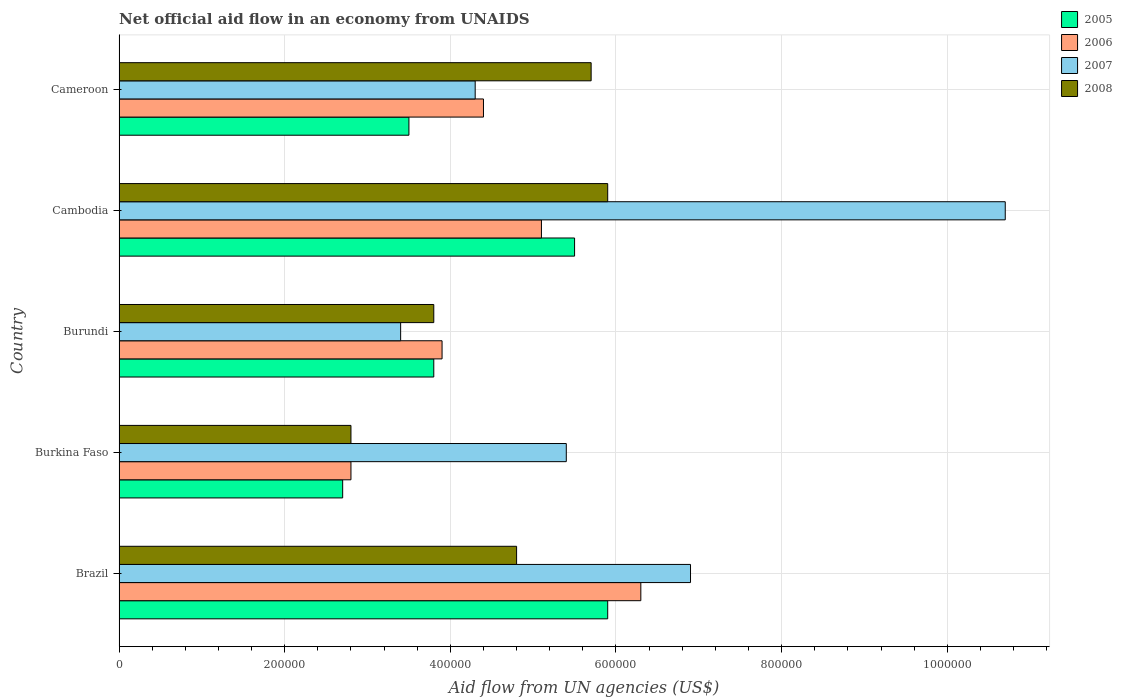Are the number of bars on each tick of the Y-axis equal?
Ensure brevity in your answer.  Yes. What is the label of the 2nd group of bars from the top?
Provide a succinct answer. Cambodia. In how many cases, is the number of bars for a given country not equal to the number of legend labels?
Your answer should be very brief. 0. What is the net official aid flow in 2007 in Burkina Faso?
Provide a succinct answer. 5.40e+05. Across all countries, what is the maximum net official aid flow in 2006?
Make the answer very short. 6.30e+05. In which country was the net official aid flow in 2005 maximum?
Offer a terse response. Brazil. In which country was the net official aid flow in 2005 minimum?
Give a very brief answer. Burkina Faso. What is the total net official aid flow in 2007 in the graph?
Your answer should be compact. 3.07e+06. What is the difference between the net official aid flow in 2005 in Burundi and that in Cambodia?
Give a very brief answer. -1.70e+05. What is the average net official aid flow in 2007 per country?
Your response must be concise. 6.14e+05. In how many countries, is the net official aid flow in 2008 greater than 1080000 US$?
Your answer should be compact. 0. What is the ratio of the net official aid flow in 2005 in Brazil to that in Burkina Faso?
Offer a terse response. 2.19. What is the difference between the highest and the lowest net official aid flow in 2006?
Provide a short and direct response. 3.50e+05. Is it the case that in every country, the sum of the net official aid flow in 2007 and net official aid flow in 2006 is greater than the sum of net official aid flow in 2008 and net official aid flow in 2005?
Offer a terse response. No. Is it the case that in every country, the sum of the net official aid flow in 2008 and net official aid flow in 2006 is greater than the net official aid flow in 2007?
Provide a short and direct response. Yes. Are all the bars in the graph horizontal?
Your answer should be compact. Yes. What is the difference between two consecutive major ticks on the X-axis?
Ensure brevity in your answer.  2.00e+05. Are the values on the major ticks of X-axis written in scientific E-notation?
Keep it short and to the point. No. Does the graph contain any zero values?
Your answer should be very brief. No. How are the legend labels stacked?
Give a very brief answer. Vertical. What is the title of the graph?
Ensure brevity in your answer.  Net official aid flow in an economy from UNAIDS. What is the label or title of the X-axis?
Your response must be concise. Aid flow from UN agencies (US$). What is the label or title of the Y-axis?
Make the answer very short. Country. What is the Aid flow from UN agencies (US$) of 2005 in Brazil?
Offer a very short reply. 5.90e+05. What is the Aid flow from UN agencies (US$) in 2006 in Brazil?
Offer a terse response. 6.30e+05. What is the Aid flow from UN agencies (US$) of 2007 in Brazil?
Ensure brevity in your answer.  6.90e+05. What is the Aid flow from UN agencies (US$) of 2008 in Brazil?
Your answer should be compact. 4.80e+05. What is the Aid flow from UN agencies (US$) in 2005 in Burkina Faso?
Offer a very short reply. 2.70e+05. What is the Aid flow from UN agencies (US$) of 2007 in Burkina Faso?
Provide a short and direct response. 5.40e+05. What is the Aid flow from UN agencies (US$) in 2008 in Burkina Faso?
Give a very brief answer. 2.80e+05. What is the Aid flow from UN agencies (US$) of 2005 in Burundi?
Keep it short and to the point. 3.80e+05. What is the Aid flow from UN agencies (US$) in 2006 in Burundi?
Give a very brief answer. 3.90e+05. What is the Aid flow from UN agencies (US$) of 2008 in Burundi?
Your answer should be compact. 3.80e+05. What is the Aid flow from UN agencies (US$) of 2006 in Cambodia?
Your answer should be compact. 5.10e+05. What is the Aid flow from UN agencies (US$) of 2007 in Cambodia?
Provide a short and direct response. 1.07e+06. What is the Aid flow from UN agencies (US$) in 2008 in Cambodia?
Provide a succinct answer. 5.90e+05. What is the Aid flow from UN agencies (US$) in 2005 in Cameroon?
Give a very brief answer. 3.50e+05. What is the Aid flow from UN agencies (US$) of 2007 in Cameroon?
Ensure brevity in your answer.  4.30e+05. What is the Aid flow from UN agencies (US$) of 2008 in Cameroon?
Offer a very short reply. 5.70e+05. Across all countries, what is the maximum Aid flow from UN agencies (US$) of 2005?
Provide a short and direct response. 5.90e+05. Across all countries, what is the maximum Aid flow from UN agencies (US$) in 2006?
Your answer should be compact. 6.30e+05. Across all countries, what is the maximum Aid flow from UN agencies (US$) in 2007?
Make the answer very short. 1.07e+06. Across all countries, what is the maximum Aid flow from UN agencies (US$) in 2008?
Provide a succinct answer. 5.90e+05. Across all countries, what is the minimum Aid flow from UN agencies (US$) in 2005?
Your answer should be very brief. 2.70e+05. Across all countries, what is the minimum Aid flow from UN agencies (US$) in 2007?
Your answer should be compact. 3.40e+05. Across all countries, what is the minimum Aid flow from UN agencies (US$) in 2008?
Keep it short and to the point. 2.80e+05. What is the total Aid flow from UN agencies (US$) of 2005 in the graph?
Offer a terse response. 2.14e+06. What is the total Aid flow from UN agencies (US$) of 2006 in the graph?
Ensure brevity in your answer.  2.25e+06. What is the total Aid flow from UN agencies (US$) in 2007 in the graph?
Give a very brief answer. 3.07e+06. What is the total Aid flow from UN agencies (US$) in 2008 in the graph?
Your response must be concise. 2.30e+06. What is the difference between the Aid flow from UN agencies (US$) in 2005 in Brazil and that in Burkina Faso?
Offer a very short reply. 3.20e+05. What is the difference between the Aid flow from UN agencies (US$) of 2007 in Brazil and that in Burkina Faso?
Make the answer very short. 1.50e+05. What is the difference between the Aid flow from UN agencies (US$) in 2005 in Brazil and that in Burundi?
Make the answer very short. 2.10e+05. What is the difference between the Aid flow from UN agencies (US$) of 2007 in Brazil and that in Burundi?
Offer a very short reply. 3.50e+05. What is the difference between the Aid flow from UN agencies (US$) of 2008 in Brazil and that in Burundi?
Ensure brevity in your answer.  1.00e+05. What is the difference between the Aid flow from UN agencies (US$) of 2007 in Brazil and that in Cambodia?
Make the answer very short. -3.80e+05. What is the difference between the Aid flow from UN agencies (US$) in 2008 in Brazil and that in Cambodia?
Ensure brevity in your answer.  -1.10e+05. What is the difference between the Aid flow from UN agencies (US$) in 2005 in Brazil and that in Cameroon?
Your answer should be compact. 2.40e+05. What is the difference between the Aid flow from UN agencies (US$) in 2006 in Brazil and that in Cameroon?
Give a very brief answer. 1.90e+05. What is the difference between the Aid flow from UN agencies (US$) of 2006 in Burkina Faso and that in Burundi?
Your answer should be compact. -1.10e+05. What is the difference between the Aid flow from UN agencies (US$) of 2005 in Burkina Faso and that in Cambodia?
Offer a very short reply. -2.80e+05. What is the difference between the Aid flow from UN agencies (US$) of 2007 in Burkina Faso and that in Cambodia?
Provide a succinct answer. -5.30e+05. What is the difference between the Aid flow from UN agencies (US$) of 2008 in Burkina Faso and that in Cambodia?
Offer a terse response. -3.10e+05. What is the difference between the Aid flow from UN agencies (US$) in 2005 in Burkina Faso and that in Cameroon?
Your response must be concise. -8.00e+04. What is the difference between the Aid flow from UN agencies (US$) of 2006 in Burkina Faso and that in Cameroon?
Provide a short and direct response. -1.60e+05. What is the difference between the Aid flow from UN agencies (US$) of 2005 in Burundi and that in Cambodia?
Make the answer very short. -1.70e+05. What is the difference between the Aid flow from UN agencies (US$) in 2006 in Burundi and that in Cambodia?
Offer a terse response. -1.20e+05. What is the difference between the Aid flow from UN agencies (US$) of 2007 in Burundi and that in Cambodia?
Offer a very short reply. -7.30e+05. What is the difference between the Aid flow from UN agencies (US$) of 2006 in Burundi and that in Cameroon?
Offer a terse response. -5.00e+04. What is the difference between the Aid flow from UN agencies (US$) of 2007 in Burundi and that in Cameroon?
Your response must be concise. -9.00e+04. What is the difference between the Aid flow from UN agencies (US$) of 2008 in Burundi and that in Cameroon?
Your answer should be very brief. -1.90e+05. What is the difference between the Aid flow from UN agencies (US$) in 2005 in Cambodia and that in Cameroon?
Provide a short and direct response. 2.00e+05. What is the difference between the Aid flow from UN agencies (US$) in 2006 in Cambodia and that in Cameroon?
Offer a terse response. 7.00e+04. What is the difference between the Aid flow from UN agencies (US$) in 2007 in Cambodia and that in Cameroon?
Offer a very short reply. 6.40e+05. What is the difference between the Aid flow from UN agencies (US$) in 2008 in Cambodia and that in Cameroon?
Your answer should be very brief. 2.00e+04. What is the difference between the Aid flow from UN agencies (US$) in 2005 in Brazil and the Aid flow from UN agencies (US$) in 2007 in Burkina Faso?
Offer a very short reply. 5.00e+04. What is the difference between the Aid flow from UN agencies (US$) of 2005 in Brazil and the Aid flow from UN agencies (US$) of 2008 in Burkina Faso?
Your answer should be compact. 3.10e+05. What is the difference between the Aid flow from UN agencies (US$) of 2006 in Brazil and the Aid flow from UN agencies (US$) of 2007 in Burkina Faso?
Provide a succinct answer. 9.00e+04. What is the difference between the Aid flow from UN agencies (US$) in 2007 in Brazil and the Aid flow from UN agencies (US$) in 2008 in Burkina Faso?
Your response must be concise. 4.10e+05. What is the difference between the Aid flow from UN agencies (US$) in 2005 in Brazil and the Aid flow from UN agencies (US$) in 2008 in Burundi?
Provide a succinct answer. 2.10e+05. What is the difference between the Aid flow from UN agencies (US$) in 2006 in Brazil and the Aid flow from UN agencies (US$) in 2008 in Burundi?
Your response must be concise. 2.50e+05. What is the difference between the Aid flow from UN agencies (US$) in 2007 in Brazil and the Aid flow from UN agencies (US$) in 2008 in Burundi?
Your response must be concise. 3.10e+05. What is the difference between the Aid flow from UN agencies (US$) in 2005 in Brazil and the Aid flow from UN agencies (US$) in 2006 in Cambodia?
Keep it short and to the point. 8.00e+04. What is the difference between the Aid flow from UN agencies (US$) in 2005 in Brazil and the Aid flow from UN agencies (US$) in 2007 in Cambodia?
Make the answer very short. -4.80e+05. What is the difference between the Aid flow from UN agencies (US$) in 2005 in Brazil and the Aid flow from UN agencies (US$) in 2008 in Cambodia?
Make the answer very short. 0. What is the difference between the Aid flow from UN agencies (US$) of 2006 in Brazil and the Aid flow from UN agencies (US$) of 2007 in Cambodia?
Your answer should be very brief. -4.40e+05. What is the difference between the Aid flow from UN agencies (US$) of 2006 in Brazil and the Aid flow from UN agencies (US$) of 2008 in Cambodia?
Give a very brief answer. 4.00e+04. What is the difference between the Aid flow from UN agencies (US$) of 2007 in Brazil and the Aid flow from UN agencies (US$) of 2008 in Cambodia?
Offer a very short reply. 1.00e+05. What is the difference between the Aid flow from UN agencies (US$) in 2005 in Brazil and the Aid flow from UN agencies (US$) in 2007 in Cameroon?
Ensure brevity in your answer.  1.60e+05. What is the difference between the Aid flow from UN agencies (US$) in 2005 in Brazil and the Aid flow from UN agencies (US$) in 2008 in Cameroon?
Give a very brief answer. 2.00e+04. What is the difference between the Aid flow from UN agencies (US$) in 2007 in Brazil and the Aid flow from UN agencies (US$) in 2008 in Cameroon?
Ensure brevity in your answer.  1.20e+05. What is the difference between the Aid flow from UN agencies (US$) in 2005 in Burkina Faso and the Aid flow from UN agencies (US$) in 2006 in Burundi?
Your response must be concise. -1.20e+05. What is the difference between the Aid flow from UN agencies (US$) of 2005 in Burkina Faso and the Aid flow from UN agencies (US$) of 2007 in Burundi?
Your response must be concise. -7.00e+04. What is the difference between the Aid flow from UN agencies (US$) of 2005 in Burkina Faso and the Aid flow from UN agencies (US$) of 2008 in Burundi?
Your answer should be compact. -1.10e+05. What is the difference between the Aid flow from UN agencies (US$) of 2006 in Burkina Faso and the Aid flow from UN agencies (US$) of 2007 in Burundi?
Keep it short and to the point. -6.00e+04. What is the difference between the Aid flow from UN agencies (US$) in 2006 in Burkina Faso and the Aid flow from UN agencies (US$) in 2008 in Burundi?
Give a very brief answer. -1.00e+05. What is the difference between the Aid flow from UN agencies (US$) of 2005 in Burkina Faso and the Aid flow from UN agencies (US$) of 2007 in Cambodia?
Provide a succinct answer. -8.00e+05. What is the difference between the Aid flow from UN agencies (US$) in 2005 in Burkina Faso and the Aid flow from UN agencies (US$) in 2008 in Cambodia?
Keep it short and to the point. -3.20e+05. What is the difference between the Aid flow from UN agencies (US$) in 2006 in Burkina Faso and the Aid flow from UN agencies (US$) in 2007 in Cambodia?
Give a very brief answer. -7.90e+05. What is the difference between the Aid flow from UN agencies (US$) in 2006 in Burkina Faso and the Aid flow from UN agencies (US$) in 2008 in Cambodia?
Make the answer very short. -3.10e+05. What is the difference between the Aid flow from UN agencies (US$) of 2006 in Burkina Faso and the Aid flow from UN agencies (US$) of 2008 in Cameroon?
Your response must be concise. -2.90e+05. What is the difference between the Aid flow from UN agencies (US$) in 2007 in Burkina Faso and the Aid flow from UN agencies (US$) in 2008 in Cameroon?
Your answer should be very brief. -3.00e+04. What is the difference between the Aid flow from UN agencies (US$) in 2005 in Burundi and the Aid flow from UN agencies (US$) in 2006 in Cambodia?
Keep it short and to the point. -1.30e+05. What is the difference between the Aid flow from UN agencies (US$) in 2005 in Burundi and the Aid flow from UN agencies (US$) in 2007 in Cambodia?
Provide a short and direct response. -6.90e+05. What is the difference between the Aid flow from UN agencies (US$) of 2006 in Burundi and the Aid flow from UN agencies (US$) of 2007 in Cambodia?
Offer a terse response. -6.80e+05. What is the difference between the Aid flow from UN agencies (US$) of 2007 in Burundi and the Aid flow from UN agencies (US$) of 2008 in Cambodia?
Offer a very short reply. -2.50e+05. What is the difference between the Aid flow from UN agencies (US$) of 2005 in Burundi and the Aid flow from UN agencies (US$) of 2006 in Cameroon?
Give a very brief answer. -6.00e+04. What is the difference between the Aid flow from UN agencies (US$) in 2005 in Burundi and the Aid flow from UN agencies (US$) in 2007 in Cameroon?
Give a very brief answer. -5.00e+04. What is the difference between the Aid flow from UN agencies (US$) of 2006 in Burundi and the Aid flow from UN agencies (US$) of 2007 in Cameroon?
Ensure brevity in your answer.  -4.00e+04. What is the difference between the Aid flow from UN agencies (US$) in 2006 in Burundi and the Aid flow from UN agencies (US$) in 2008 in Cameroon?
Make the answer very short. -1.80e+05. What is the difference between the Aid flow from UN agencies (US$) of 2007 in Cambodia and the Aid flow from UN agencies (US$) of 2008 in Cameroon?
Your answer should be compact. 5.00e+05. What is the average Aid flow from UN agencies (US$) of 2005 per country?
Make the answer very short. 4.28e+05. What is the average Aid flow from UN agencies (US$) of 2006 per country?
Offer a terse response. 4.50e+05. What is the average Aid flow from UN agencies (US$) in 2007 per country?
Keep it short and to the point. 6.14e+05. What is the average Aid flow from UN agencies (US$) of 2008 per country?
Your answer should be very brief. 4.60e+05. What is the difference between the Aid flow from UN agencies (US$) in 2005 and Aid flow from UN agencies (US$) in 2008 in Brazil?
Ensure brevity in your answer.  1.10e+05. What is the difference between the Aid flow from UN agencies (US$) of 2006 and Aid flow from UN agencies (US$) of 2007 in Brazil?
Provide a succinct answer. -6.00e+04. What is the difference between the Aid flow from UN agencies (US$) in 2007 and Aid flow from UN agencies (US$) in 2008 in Brazil?
Offer a very short reply. 2.10e+05. What is the difference between the Aid flow from UN agencies (US$) in 2005 and Aid flow from UN agencies (US$) in 2007 in Burkina Faso?
Your answer should be very brief. -2.70e+05. What is the difference between the Aid flow from UN agencies (US$) in 2005 and Aid flow from UN agencies (US$) in 2008 in Burkina Faso?
Ensure brevity in your answer.  -10000. What is the difference between the Aid flow from UN agencies (US$) of 2007 and Aid flow from UN agencies (US$) of 2008 in Burkina Faso?
Your response must be concise. 2.60e+05. What is the difference between the Aid flow from UN agencies (US$) of 2005 and Aid flow from UN agencies (US$) of 2006 in Burundi?
Your response must be concise. -10000. What is the difference between the Aid flow from UN agencies (US$) in 2005 and Aid flow from UN agencies (US$) in 2007 in Burundi?
Your answer should be compact. 4.00e+04. What is the difference between the Aid flow from UN agencies (US$) in 2007 and Aid flow from UN agencies (US$) in 2008 in Burundi?
Provide a succinct answer. -4.00e+04. What is the difference between the Aid flow from UN agencies (US$) in 2005 and Aid flow from UN agencies (US$) in 2007 in Cambodia?
Your response must be concise. -5.20e+05. What is the difference between the Aid flow from UN agencies (US$) of 2005 and Aid flow from UN agencies (US$) of 2008 in Cambodia?
Your response must be concise. -4.00e+04. What is the difference between the Aid flow from UN agencies (US$) in 2006 and Aid flow from UN agencies (US$) in 2007 in Cambodia?
Your answer should be compact. -5.60e+05. What is the difference between the Aid flow from UN agencies (US$) of 2006 and Aid flow from UN agencies (US$) of 2008 in Cambodia?
Your response must be concise. -8.00e+04. What is the difference between the Aid flow from UN agencies (US$) of 2007 and Aid flow from UN agencies (US$) of 2008 in Cambodia?
Keep it short and to the point. 4.80e+05. What is the difference between the Aid flow from UN agencies (US$) of 2005 and Aid flow from UN agencies (US$) of 2008 in Cameroon?
Your response must be concise. -2.20e+05. What is the difference between the Aid flow from UN agencies (US$) in 2006 and Aid flow from UN agencies (US$) in 2008 in Cameroon?
Your answer should be very brief. -1.30e+05. What is the difference between the Aid flow from UN agencies (US$) of 2007 and Aid flow from UN agencies (US$) of 2008 in Cameroon?
Offer a very short reply. -1.40e+05. What is the ratio of the Aid flow from UN agencies (US$) in 2005 in Brazil to that in Burkina Faso?
Ensure brevity in your answer.  2.19. What is the ratio of the Aid flow from UN agencies (US$) of 2006 in Brazil to that in Burkina Faso?
Offer a terse response. 2.25. What is the ratio of the Aid flow from UN agencies (US$) in 2007 in Brazil to that in Burkina Faso?
Offer a terse response. 1.28. What is the ratio of the Aid flow from UN agencies (US$) in 2008 in Brazil to that in Burkina Faso?
Offer a terse response. 1.71. What is the ratio of the Aid flow from UN agencies (US$) in 2005 in Brazil to that in Burundi?
Keep it short and to the point. 1.55. What is the ratio of the Aid flow from UN agencies (US$) in 2006 in Brazil to that in Burundi?
Your answer should be compact. 1.62. What is the ratio of the Aid flow from UN agencies (US$) in 2007 in Brazil to that in Burundi?
Your answer should be very brief. 2.03. What is the ratio of the Aid flow from UN agencies (US$) in 2008 in Brazil to that in Burundi?
Your answer should be very brief. 1.26. What is the ratio of the Aid flow from UN agencies (US$) in 2005 in Brazil to that in Cambodia?
Provide a succinct answer. 1.07. What is the ratio of the Aid flow from UN agencies (US$) in 2006 in Brazil to that in Cambodia?
Your answer should be compact. 1.24. What is the ratio of the Aid flow from UN agencies (US$) of 2007 in Brazil to that in Cambodia?
Offer a terse response. 0.64. What is the ratio of the Aid flow from UN agencies (US$) of 2008 in Brazil to that in Cambodia?
Give a very brief answer. 0.81. What is the ratio of the Aid flow from UN agencies (US$) of 2005 in Brazil to that in Cameroon?
Provide a succinct answer. 1.69. What is the ratio of the Aid flow from UN agencies (US$) of 2006 in Brazil to that in Cameroon?
Your answer should be compact. 1.43. What is the ratio of the Aid flow from UN agencies (US$) of 2007 in Brazil to that in Cameroon?
Provide a short and direct response. 1.6. What is the ratio of the Aid flow from UN agencies (US$) in 2008 in Brazil to that in Cameroon?
Give a very brief answer. 0.84. What is the ratio of the Aid flow from UN agencies (US$) of 2005 in Burkina Faso to that in Burundi?
Give a very brief answer. 0.71. What is the ratio of the Aid flow from UN agencies (US$) in 2006 in Burkina Faso to that in Burundi?
Keep it short and to the point. 0.72. What is the ratio of the Aid flow from UN agencies (US$) of 2007 in Burkina Faso to that in Burundi?
Your response must be concise. 1.59. What is the ratio of the Aid flow from UN agencies (US$) of 2008 in Burkina Faso to that in Burundi?
Offer a terse response. 0.74. What is the ratio of the Aid flow from UN agencies (US$) in 2005 in Burkina Faso to that in Cambodia?
Your answer should be very brief. 0.49. What is the ratio of the Aid flow from UN agencies (US$) of 2006 in Burkina Faso to that in Cambodia?
Offer a terse response. 0.55. What is the ratio of the Aid flow from UN agencies (US$) in 2007 in Burkina Faso to that in Cambodia?
Make the answer very short. 0.5. What is the ratio of the Aid flow from UN agencies (US$) in 2008 in Burkina Faso to that in Cambodia?
Provide a short and direct response. 0.47. What is the ratio of the Aid flow from UN agencies (US$) of 2005 in Burkina Faso to that in Cameroon?
Your answer should be very brief. 0.77. What is the ratio of the Aid flow from UN agencies (US$) of 2006 in Burkina Faso to that in Cameroon?
Your response must be concise. 0.64. What is the ratio of the Aid flow from UN agencies (US$) of 2007 in Burkina Faso to that in Cameroon?
Provide a short and direct response. 1.26. What is the ratio of the Aid flow from UN agencies (US$) of 2008 in Burkina Faso to that in Cameroon?
Your answer should be very brief. 0.49. What is the ratio of the Aid flow from UN agencies (US$) in 2005 in Burundi to that in Cambodia?
Your answer should be compact. 0.69. What is the ratio of the Aid flow from UN agencies (US$) in 2006 in Burundi to that in Cambodia?
Offer a very short reply. 0.76. What is the ratio of the Aid flow from UN agencies (US$) of 2007 in Burundi to that in Cambodia?
Your answer should be very brief. 0.32. What is the ratio of the Aid flow from UN agencies (US$) in 2008 in Burundi to that in Cambodia?
Keep it short and to the point. 0.64. What is the ratio of the Aid flow from UN agencies (US$) in 2005 in Burundi to that in Cameroon?
Give a very brief answer. 1.09. What is the ratio of the Aid flow from UN agencies (US$) of 2006 in Burundi to that in Cameroon?
Keep it short and to the point. 0.89. What is the ratio of the Aid flow from UN agencies (US$) in 2007 in Burundi to that in Cameroon?
Offer a terse response. 0.79. What is the ratio of the Aid flow from UN agencies (US$) of 2008 in Burundi to that in Cameroon?
Provide a succinct answer. 0.67. What is the ratio of the Aid flow from UN agencies (US$) of 2005 in Cambodia to that in Cameroon?
Make the answer very short. 1.57. What is the ratio of the Aid flow from UN agencies (US$) in 2006 in Cambodia to that in Cameroon?
Keep it short and to the point. 1.16. What is the ratio of the Aid flow from UN agencies (US$) of 2007 in Cambodia to that in Cameroon?
Your response must be concise. 2.49. What is the ratio of the Aid flow from UN agencies (US$) of 2008 in Cambodia to that in Cameroon?
Ensure brevity in your answer.  1.04. What is the difference between the highest and the second highest Aid flow from UN agencies (US$) in 2005?
Your answer should be very brief. 4.00e+04. What is the difference between the highest and the lowest Aid flow from UN agencies (US$) in 2006?
Make the answer very short. 3.50e+05. What is the difference between the highest and the lowest Aid flow from UN agencies (US$) of 2007?
Your response must be concise. 7.30e+05. 